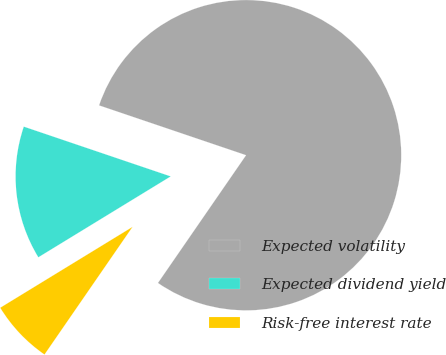<chart> <loc_0><loc_0><loc_500><loc_500><pie_chart><fcel>Expected volatility<fcel>Expected dividend yield<fcel>Risk-free interest rate<nl><fcel>79.41%<fcel>13.93%<fcel>6.66%<nl></chart> 